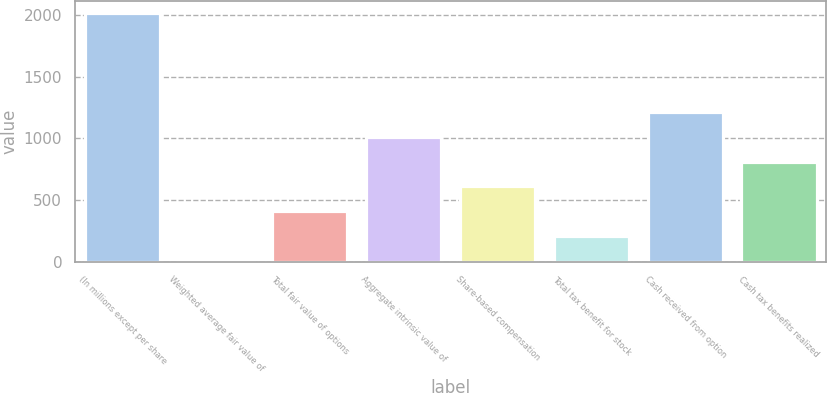<chart> <loc_0><loc_0><loc_500><loc_500><bar_chart><fcel>(In millions except per share<fcel>Weighted average fair value of<fcel>Total fair value of options<fcel>Aggregate intrinsic value of<fcel>Share-based compensation<fcel>Total tax benefit for stock<fcel>Cash received from option<fcel>Cash tax benefits realized<nl><fcel>2013<fcel>11.24<fcel>411.6<fcel>1012.14<fcel>611.78<fcel>211.42<fcel>1212.32<fcel>811.96<nl></chart> 